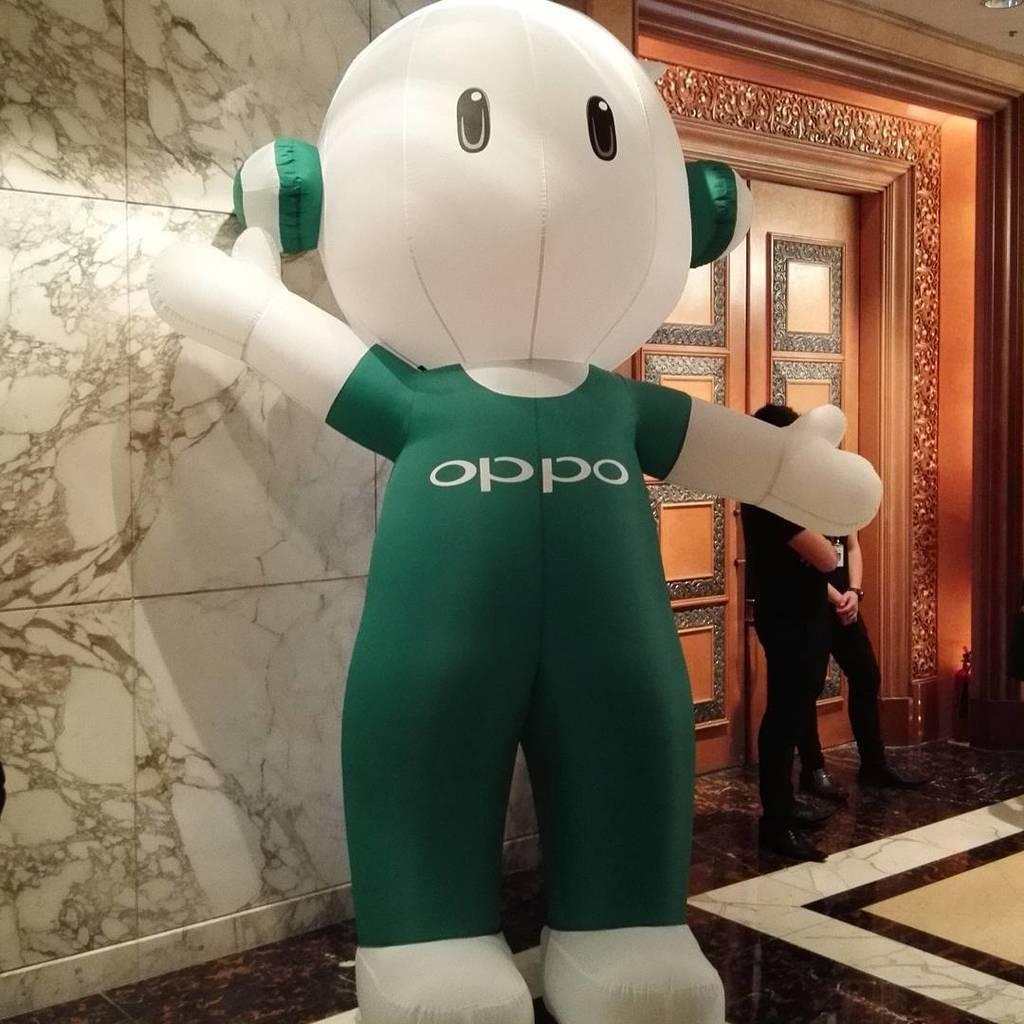What type of location is depicted in the image? The image shows an inner view of a building. What can be seen inside the building? There is an air balloon in the image. Are there any people visible in the image? Yes, there are people standing at the door in the image. What type of beast can be seen interacting with the air balloon in the image? There is no beast present in the image, and therefore no such interaction can be observed. 